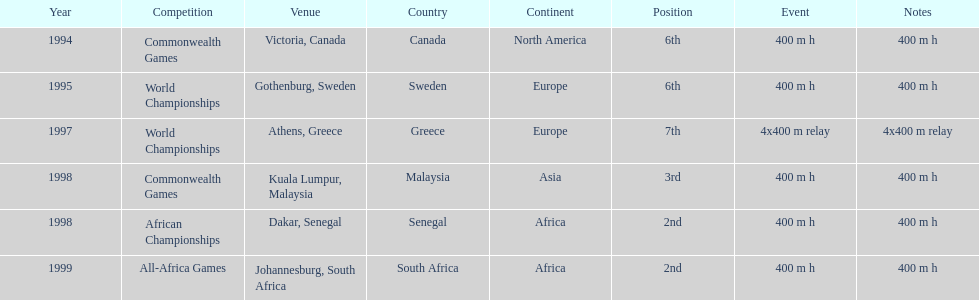In what years did ken harnden do better that 5th place? 1998, 1999. 